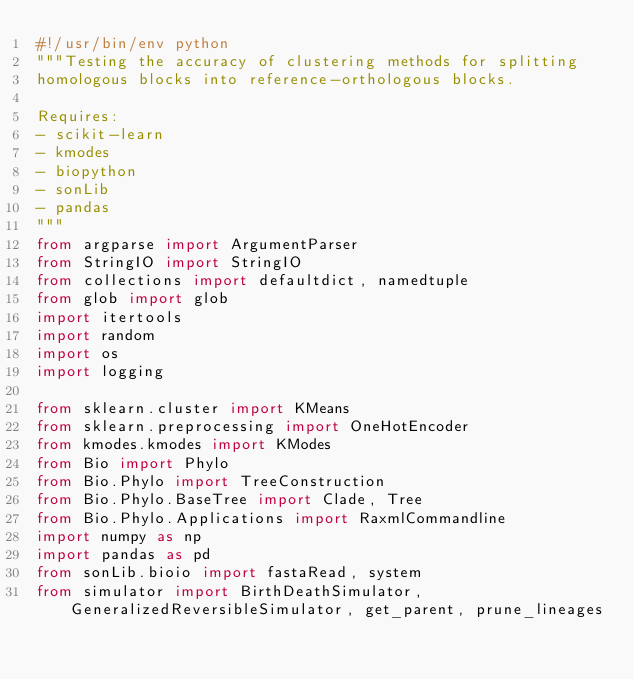<code> <loc_0><loc_0><loc_500><loc_500><_Python_>#!/usr/bin/env python
"""Testing the accuracy of clustering methods for splitting
homologous blocks into reference-orthologous blocks.

Requires:
- scikit-learn
- kmodes
- biopython
- sonLib
- pandas
"""
from argparse import ArgumentParser
from StringIO import StringIO
from collections import defaultdict, namedtuple
from glob import glob
import itertools
import random
import os
import logging

from sklearn.cluster import KMeans
from sklearn.preprocessing import OneHotEncoder
from kmodes.kmodes import KModes
from Bio import Phylo
from Bio.Phylo import TreeConstruction
from Bio.Phylo.BaseTree import Clade, Tree
from Bio.Phylo.Applications import RaxmlCommandline
import numpy as np
import pandas as pd
from sonLib.bioio import fastaRead, system
from simulator import BirthDeathSimulator, GeneralizedReversibleSimulator, get_parent, prune_lineages
</code> 